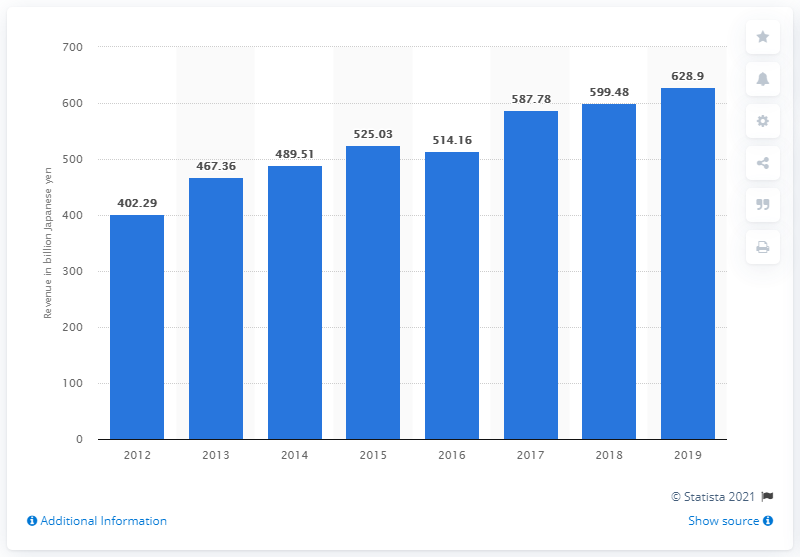Mention a couple of crucial points in this snapshot. Terumo Corporation's revenue in 2019 was 628.9 billion yen. 